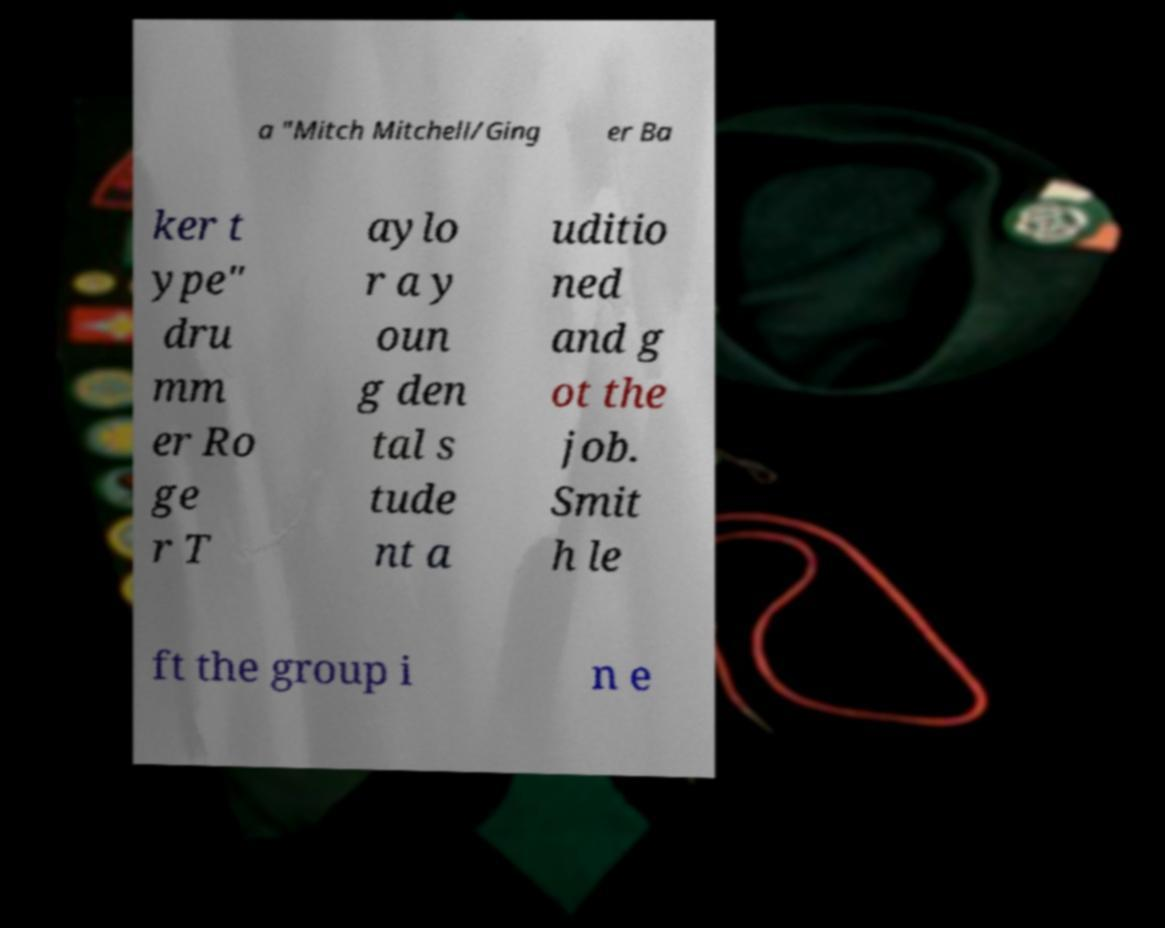There's text embedded in this image that I need extracted. Can you transcribe it verbatim? a "Mitch Mitchell/Ging er Ba ker t ype" dru mm er Ro ge r T aylo r a y oun g den tal s tude nt a uditio ned and g ot the job. Smit h le ft the group i n e 